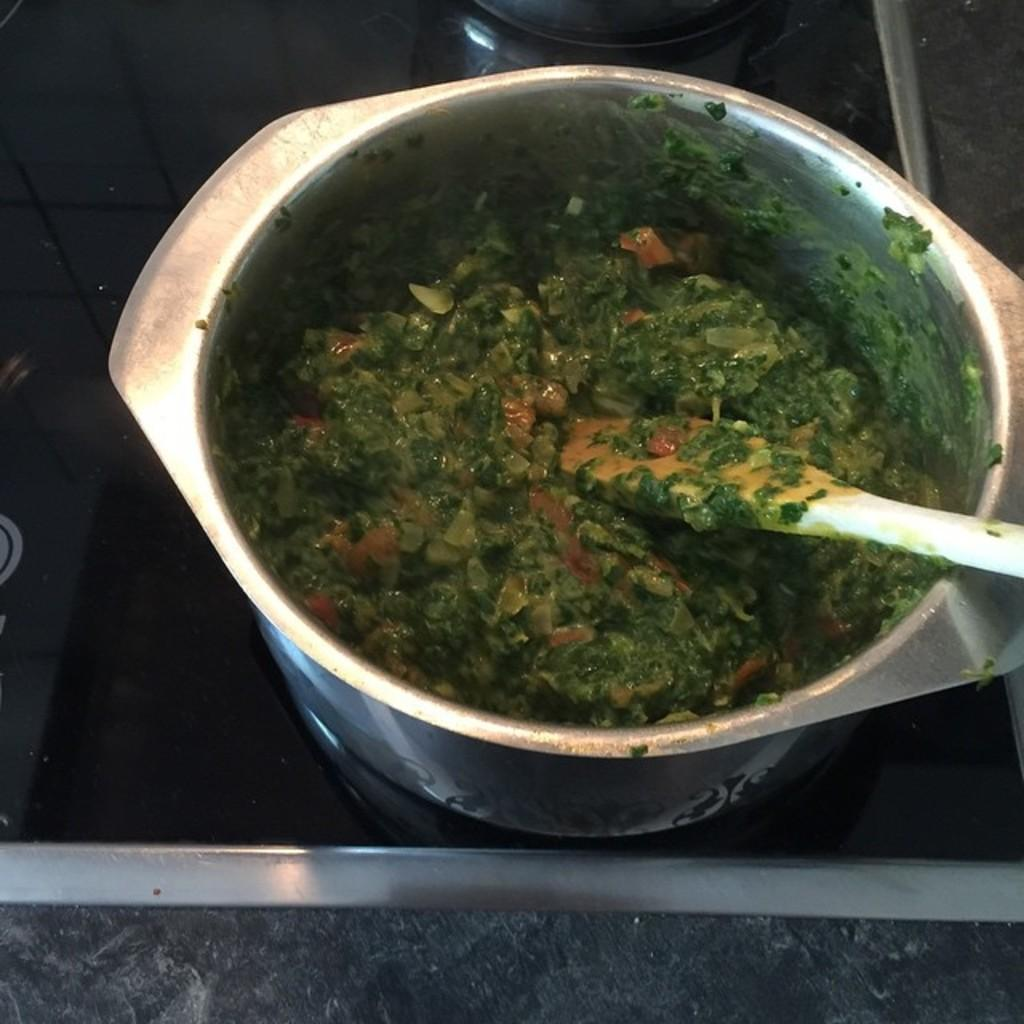What is in the food container that is visible in the image? The food container contains food. What utensil is present in the image? There is a spatula in the image. What is the color of the surface on which the food container is placed? The food container is on a black surface. What type of pear is being used by the company on this particular day in the image? There is no pear, company, or day mentioned in the image. The image only shows a food container with food and a spatula on a black surface. 